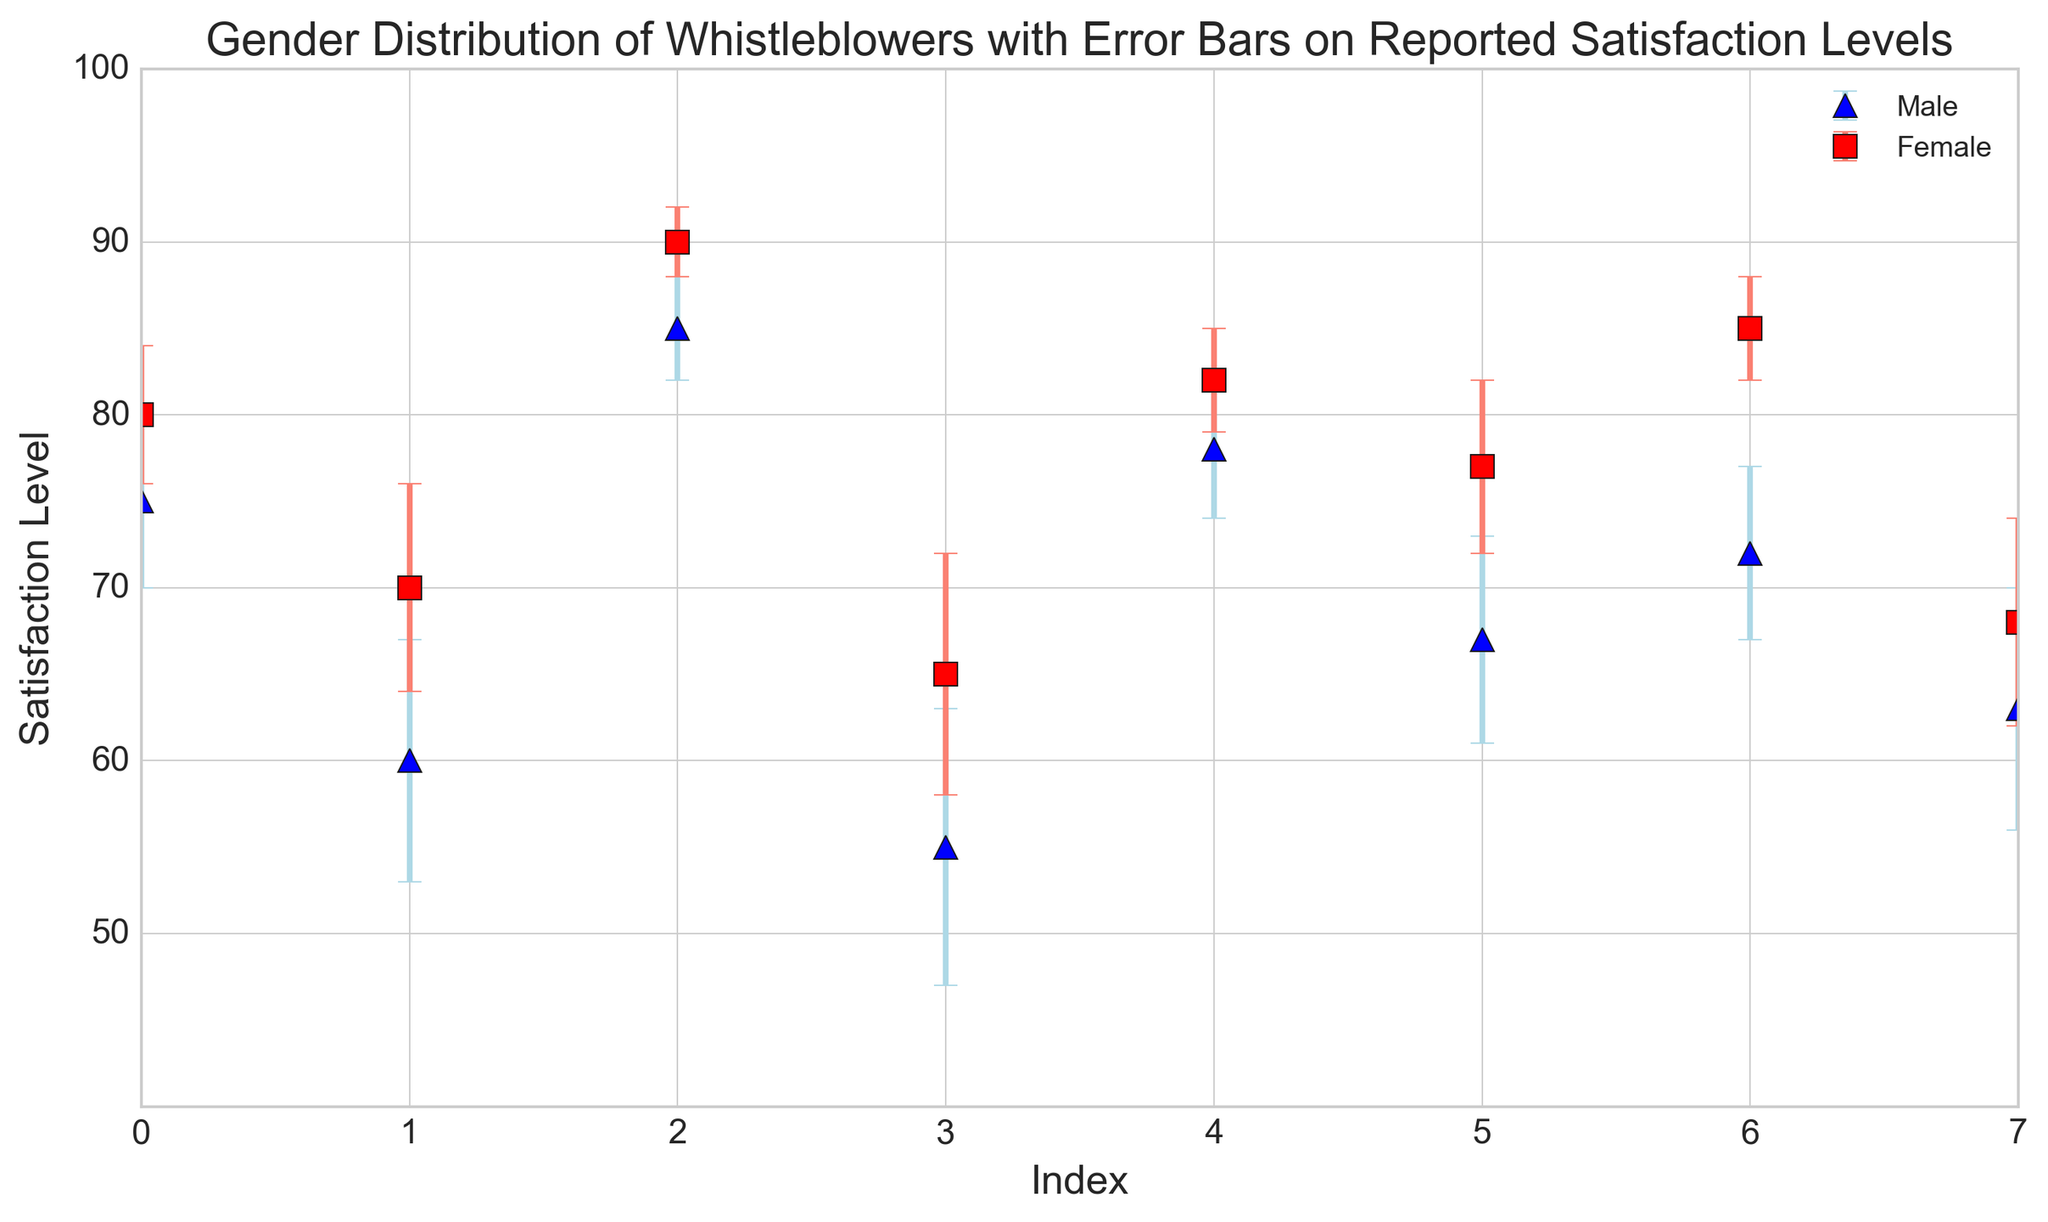Which gender has the highest satisfaction level among whistleblowers? From the figure, the highest data point on the y-axis belongs to the female category with a satisfaction level of 90.
Answer: Female How does the error bar for the highest male satisfaction level compare to the highest female satisfaction level? The highest male satisfaction level (85) has an error bar of 3, while the highest female satisfaction level (90) has an error bar of 2. So, the error bar for the highest male satisfaction level is larger.
Answer: Male error bar is larger What is the average satisfaction level for male whistleblowers? The satisfaction levels for male whistleblowers are 75, 60, 85, 55, 78, 67, 72, and 63. Summing them gives 555, and dividing by 8 yields an average of 69.375.
Answer: 69.375 Which gender generally appears to have a higher satisfaction level based on the data points? By visually comparing the red and blue markers on the figure, it appears that the red markers (female) are generally higher than the blue markers (male).
Answer: Female What is the range of error bars for female whistleblowers? The error bars for female whistleblowers range from 2 to 7, which can be seen from the different sized error bars next to the red markers.
Answer: 2 to 7 Are there any male satisfaction levels that are significantly lower compared to the rest? By visually inspecting the figure, the male satisfaction levels at indexes 1 and 3 (60 and 55) appear significantly lower compared to other male satisfaction levels.
Answer: Yes Between index 4 and index 5 for both genders, which gender shows less variation in satisfaction levels considering error bars? At indexes 4 and 5, male satisfaction levels are 78 and 67 with error bars of 4 and 6 respectively; female satisfaction levels are 82 and 77 with error bars of 3 and 5 respectively. Female shows less variation considering the error bars.
Answer: Female Which index shows the maximum difference in satisfaction levels between genders? The index with the maximum difference is where male is at 55 (index 3) and female is at 65 (index 3), resulting in a difference of 10.
Answer: Index 3 What is the total sum of satisfaction levels for female whistleblowers? Summing the satisfaction levels for female whistleblowers (80, 70, 90, 65, 82, 77, 85, and 68), we get a total of 617.
Answer: 617 